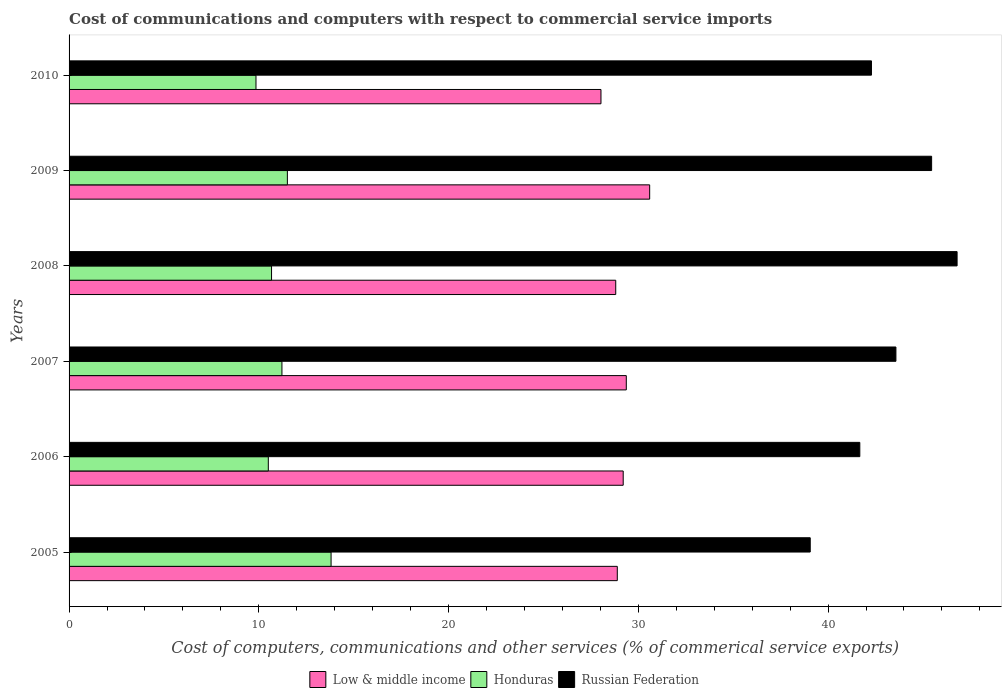How many groups of bars are there?
Your answer should be compact. 6. Are the number of bars per tick equal to the number of legend labels?
Provide a short and direct response. Yes. How many bars are there on the 6th tick from the top?
Provide a short and direct response. 3. What is the cost of communications and computers in Russian Federation in 2005?
Provide a succinct answer. 39.06. Across all years, what is the maximum cost of communications and computers in Russian Federation?
Make the answer very short. 46.8. Across all years, what is the minimum cost of communications and computers in Russian Federation?
Ensure brevity in your answer.  39.06. In which year was the cost of communications and computers in Low & middle income maximum?
Provide a succinct answer. 2009. In which year was the cost of communications and computers in Low & middle income minimum?
Provide a succinct answer. 2010. What is the total cost of communications and computers in Honduras in the graph?
Your answer should be compact. 67.55. What is the difference between the cost of communications and computers in Russian Federation in 2008 and that in 2009?
Give a very brief answer. 1.34. What is the difference between the cost of communications and computers in Low & middle income in 2005 and the cost of communications and computers in Russian Federation in 2008?
Keep it short and to the point. -17.91. What is the average cost of communications and computers in Honduras per year?
Your answer should be compact. 11.26. In the year 2010, what is the difference between the cost of communications and computers in Russian Federation and cost of communications and computers in Honduras?
Make the answer very short. 32.44. In how many years, is the cost of communications and computers in Honduras greater than 30 %?
Your response must be concise. 0. What is the ratio of the cost of communications and computers in Low & middle income in 2006 to that in 2010?
Provide a succinct answer. 1.04. Is the cost of communications and computers in Honduras in 2005 less than that in 2008?
Keep it short and to the point. No. What is the difference between the highest and the second highest cost of communications and computers in Russian Federation?
Your response must be concise. 1.34. What is the difference between the highest and the lowest cost of communications and computers in Honduras?
Make the answer very short. 3.96. In how many years, is the cost of communications and computers in Russian Federation greater than the average cost of communications and computers in Russian Federation taken over all years?
Keep it short and to the point. 3. Is the sum of the cost of communications and computers in Russian Federation in 2006 and 2007 greater than the maximum cost of communications and computers in Honduras across all years?
Make the answer very short. Yes. What does the 1st bar from the top in 2005 represents?
Make the answer very short. Russian Federation. What does the 3rd bar from the bottom in 2008 represents?
Provide a short and direct response. Russian Federation. Is it the case that in every year, the sum of the cost of communications and computers in Low & middle income and cost of communications and computers in Honduras is greater than the cost of communications and computers in Russian Federation?
Ensure brevity in your answer.  No. How many bars are there?
Provide a succinct answer. 18. Are all the bars in the graph horizontal?
Provide a succinct answer. Yes. What is the difference between two consecutive major ticks on the X-axis?
Provide a succinct answer. 10. Where does the legend appear in the graph?
Make the answer very short. Bottom center. How many legend labels are there?
Your answer should be very brief. 3. What is the title of the graph?
Your answer should be compact. Cost of communications and computers with respect to commercial service imports. Does "Heavily indebted poor countries" appear as one of the legend labels in the graph?
Provide a short and direct response. No. What is the label or title of the X-axis?
Keep it short and to the point. Cost of computers, communications and other services (% of commerical service exports). What is the Cost of computers, communications and other services (% of commerical service exports) in Low & middle income in 2005?
Your answer should be compact. 28.89. What is the Cost of computers, communications and other services (% of commerical service exports) in Honduras in 2005?
Keep it short and to the point. 13.81. What is the Cost of computers, communications and other services (% of commerical service exports) in Russian Federation in 2005?
Offer a terse response. 39.06. What is the Cost of computers, communications and other services (% of commerical service exports) of Low & middle income in 2006?
Give a very brief answer. 29.2. What is the Cost of computers, communications and other services (% of commerical service exports) in Honduras in 2006?
Make the answer very short. 10.5. What is the Cost of computers, communications and other services (% of commerical service exports) of Russian Federation in 2006?
Ensure brevity in your answer.  41.67. What is the Cost of computers, communications and other services (% of commerical service exports) of Low & middle income in 2007?
Provide a short and direct response. 29.37. What is the Cost of computers, communications and other services (% of commerical service exports) of Honduras in 2007?
Keep it short and to the point. 11.22. What is the Cost of computers, communications and other services (% of commerical service exports) of Russian Federation in 2007?
Keep it short and to the point. 43.57. What is the Cost of computers, communications and other services (% of commerical service exports) in Low & middle income in 2008?
Offer a very short reply. 28.81. What is the Cost of computers, communications and other services (% of commerical service exports) of Honduras in 2008?
Give a very brief answer. 10.67. What is the Cost of computers, communications and other services (% of commerical service exports) in Russian Federation in 2008?
Keep it short and to the point. 46.8. What is the Cost of computers, communications and other services (% of commerical service exports) of Low & middle income in 2009?
Your answer should be very brief. 30.6. What is the Cost of computers, communications and other services (% of commerical service exports) in Honduras in 2009?
Keep it short and to the point. 11.5. What is the Cost of computers, communications and other services (% of commerical service exports) of Russian Federation in 2009?
Your response must be concise. 45.46. What is the Cost of computers, communications and other services (% of commerical service exports) of Low & middle income in 2010?
Your answer should be compact. 28.03. What is the Cost of computers, communications and other services (% of commerical service exports) of Honduras in 2010?
Make the answer very short. 9.85. What is the Cost of computers, communications and other services (% of commerical service exports) of Russian Federation in 2010?
Your response must be concise. 42.29. Across all years, what is the maximum Cost of computers, communications and other services (% of commerical service exports) in Low & middle income?
Give a very brief answer. 30.6. Across all years, what is the maximum Cost of computers, communications and other services (% of commerical service exports) in Honduras?
Ensure brevity in your answer.  13.81. Across all years, what is the maximum Cost of computers, communications and other services (% of commerical service exports) of Russian Federation?
Give a very brief answer. 46.8. Across all years, what is the minimum Cost of computers, communications and other services (% of commerical service exports) in Low & middle income?
Keep it short and to the point. 28.03. Across all years, what is the minimum Cost of computers, communications and other services (% of commerical service exports) in Honduras?
Provide a short and direct response. 9.85. Across all years, what is the minimum Cost of computers, communications and other services (% of commerical service exports) of Russian Federation?
Provide a succinct answer. 39.06. What is the total Cost of computers, communications and other services (% of commerical service exports) of Low & middle income in the graph?
Provide a succinct answer. 174.9. What is the total Cost of computers, communications and other services (% of commerical service exports) in Honduras in the graph?
Keep it short and to the point. 67.55. What is the total Cost of computers, communications and other services (% of commerical service exports) in Russian Federation in the graph?
Keep it short and to the point. 258.85. What is the difference between the Cost of computers, communications and other services (% of commerical service exports) of Low & middle income in 2005 and that in 2006?
Provide a succinct answer. -0.31. What is the difference between the Cost of computers, communications and other services (% of commerical service exports) in Honduras in 2005 and that in 2006?
Your answer should be compact. 3.31. What is the difference between the Cost of computers, communications and other services (% of commerical service exports) in Russian Federation in 2005 and that in 2006?
Make the answer very short. -2.61. What is the difference between the Cost of computers, communications and other services (% of commerical service exports) of Low & middle income in 2005 and that in 2007?
Offer a terse response. -0.47. What is the difference between the Cost of computers, communications and other services (% of commerical service exports) in Honduras in 2005 and that in 2007?
Ensure brevity in your answer.  2.59. What is the difference between the Cost of computers, communications and other services (% of commerical service exports) of Russian Federation in 2005 and that in 2007?
Provide a succinct answer. -4.52. What is the difference between the Cost of computers, communications and other services (% of commerical service exports) of Low & middle income in 2005 and that in 2008?
Provide a short and direct response. 0.08. What is the difference between the Cost of computers, communications and other services (% of commerical service exports) in Honduras in 2005 and that in 2008?
Your answer should be compact. 3.14. What is the difference between the Cost of computers, communications and other services (% of commerical service exports) of Russian Federation in 2005 and that in 2008?
Provide a short and direct response. -7.74. What is the difference between the Cost of computers, communications and other services (% of commerical service exports) of Low & middle income in 2005 and that in 2009?
Provide a succinct answer. -1.71. What is the difference between the Cost of computers, communications and other services (% of commerical service exports) of Honduras in 2005 and that in 2009?
Ensure brevity in your answer.  2.3. What is the difference between the Cost of computers, communications and other services (% of commerical service exports) in Russian Federation in 2005 and that in 2009?
Offer a very short reply. -6.4. What is the difference between the Cost of computers, communications and other services (% of commerical service exports) in Low & middle income in 2005 and that in 2010?
Offer a terse response. 0.86. What is the difference between the Cost of computers, communications and other services (% of commerical service exports) in Honduras in 2005 and that in 2010?
Your answer should be very brief. 3.96. What is the difference between the Cost of computers, communications and other services (% of commerical service exports) of Russian Federation in 2005 and that in 2010?
Offer a terse response. -3.23. What is the difference between the Cost of computers, communications and other services (% of commerical service exports) in Low & middle income in 2006 and that in 2007?
Your answer should be compact. -0.16. What is the difference between the Cost of computers, communications and other services (% of commerical service exports) of Honduras in 2006 and that in 2007?
Your answer should be compact. -0.72. What is the difference between the Cost of computers, communications and other services (% of commerical service exports) of Russian Federation in 2006 and that in 2007?
Your response must be concise. -1.9. What is the difference between the Cost of computers, communications and other services (% of commerical service exports) of Low & middle income in 2006 and that in 2008?
Make the answer very short. 0.39. What is the difference between the Cost of computers, communications and other services (% of commerical service exports) in Honduras in 2006 and that in 2008?
Offer a very short reply. -0.17. What is the difference between the Cost of computers, communications and other services (% of commerical service exports) in Russian Federation in 2006 and that in 2008?
Make the answer very short. -5.13. What is the difference between the Cost of computers, communications and other services (% of commerical service exports) of Low & middle income in 2006 and that in 2009?
Provide a succinct answer. -1.4. What is the difference between the Cost of computers, communications and other services (% of commerical service exports) in Honduras in 2006 and that in 2009?
Your answer should be very brief. -1. What is the difference between the Cost of computers, communications and other services (% of commerical service exports) in Russian Federation in 2006 and that in 2009?
Keep it short and to the point. -3.78. What is the difference between the Cost of computers, communications and other services (% of commerical service exports) of Low & middle income in 2006 and that in 2010?
Keep it short and to the point. 1.17. What is the difference between the Cost of computers, communications and other services (% of commerical service exports) in Honduras in 2006 and that in 2010?
Offer a very short reply. 0.65. What is the difference between the Cost of computers, communications and other services (% of commerical service exports) of Russian Federation in 2006 and that in 2010?
Keep it short and to the point. -0.61. What is the difference between the Cost of computers, communications and other services (% of commerical service exports) in Low & middle income in 2007 and that in 2008?
Provide a succinct answer. 0.56. What is the difference between the Cost of computers, communications and other services (% of commerical service exports) of Honduras in 2007 and that in 2008?
Make the answer very short. 0.55. What is the difference between the Cost of computers, communications and other services (% of commerical service exports) in Russian Federation in 2007 and that in 2008?
Your response must be concise. -3.22. What is the difference between the Cost of computers, communications and other services (% of commerical service exports) in Low & middle income in 2007 and that in 2009?
Ensure brevity in your answer.  -1.23. What is the difference between the Cost of computers, communications and other services (% of commerical service exports) of Honduras in 2007 and that in 2009?
Ensure brevity in your answer.  -0.29. What is the difference between the Cost of computers, communications and other services (% of commerical service exports) of Russian Federation in 2007 and that in 2009?
Provide a succinct answer. -1.88. What is the difference between the Cost of computers, communications and other services (% of commerical service exports) in Low & middle income in 2007 and that in 2010?
Give a very brief answer. 1.33. What is the difference between the Cost of computers, communications and other services (% of commerical service exports) in Honduras in 2007 and that in 2010?
Provide a succinct answer. 1.37. What is the difference between the Cost of computers, communications and other services (% of commerical service exports) in Russian Federation in 2007 and that in 2010?
Offer a very short reply. 1.29. What is the difference between the Cost of computers, communications and other services (% of commerical service exports) in Low & middle income in 2008 and that in 2009?
Your answer should be compact. -1.79. What is the difference between the Cost of computers, communications and other services (% of commerical service exports) of Honduras in 2008 and that in 2009?
Offer a terse response. -0.83. What is the difference between the Cost of computers, communications and other services (% of commerical service exports) of Russian Federation in 2008 and that in 2009?
Offer a very short reply. 1.34. What is the difference between the Cost of computers, communications and other services (% of commerical service exports) in Low & middle income in 2008 and that in 2010?
Give a very brief answer. 0.78. What is the difference between the Cost of computers, communications and other services (% of commerical service exports) of Honduras in 2008 and that in 2010?
Keep it short and to the point. 0.82. What is the difference between the Cost of computers, communications and other services (% of commerical service exports) in Russian Federation in 2008 and that in 2010?
Make the answer very short. 4.51. What is the difference between the Cost of computers, communications and other services (% of commerical service exports) in Low & middle income in 2009 and that in 2010?
Offer a terse response. 2.57. What is the difference between the Cost of computers, communications and other services (% of commerical service exports) of Honduras in 2009 and that in 2010?
Your answer should be compact. 1.65. What is the difference between the Cost of computers, communications and other services (% of commerical service exports) in Russian Federation in 2009 and that in 2010?
Offer a terse response. 3.17. What is the difference between the Cost of computers, communications and other services (% of commerical service exports) of Low & middle income in 2005 and the Cost of computers, communications and other services (% of commerical service exports) of Honduras in 2006?
Your response must be concise. 18.39. What is the difference between the Cost of computers, communications and other services (% of commerical service exports) of Low & middle income in 2005 and the Cost of computers, communications and other services (% of commerical service exports) of Russian Federation in 2006?
Ensure brevity in your answer.  -12.78. What is the difference between the Cost of computers, communications and other services (% of commerical service exports) in Honduras in 2005 and the Cost of computers, communications and other services (% of commerical service exports) in Russian Federation in 2006?
Offer a terse response. -27.86. What is the difference between the Cost of computers, communications and other services (% of commerical service exports) of Low & middle income in 2005 and the Cost of computers, communications and other services (% of commerical service exports) of Honduras in 2007?
Provide a succinct answer. 17.67. What is the difference between the Cost of computers, communications and other services (% of commerical service exports) of Low & middle income in 2005 and the Cost of computers, communications and other services (% of commerical service exports) of Russian Federation in 2007?
Offer a terse response. -14.68. What is the difference between the Cost of computers, communications and other services (% of commerical service exports) of Honduras in 2005 and the Cost of computers, communications and other services (% of commerical service exports) of Russian Federation in 2007?
Your answer should be compact. -29.77. What is the difference between the Cost of computers, communications and other services (% of commerical service exports) of Low & middle income in 2005 and the Cost of computers, communications and other services (% of commerical service exports) of Honduras in 2008?
Keep it short and to the point. 18.22. What is the difference between the Cost of computers, communications and other services (% of commerical service exports) of Low & middle income in 2005 and the Cost of computers, communications and other services (% of commerical service exports) of Russian Federation in 2008?
Offer a very short reply. -17.91. What is the difference between the Cost of computers, communications and other services (% of commerical service exports) of Honduras in 2005 and the Cost of computers, communications and other services (% of commerical service exports) of Russian Federation in 2008?
Ensure brevity in your answer.  -32.99. What is the difference between the Cost of computers, communications and other services (% of commerical service exports) in Low & middle income in 2005 and the Cost of computers, communications and other services (% of commerical service exports) in Honduras in 2009?
Keep it short and to the point. 17.39. What is the difference between the Cost of computers, communications and other services (% of commerical service exports) in Low & middle income in 2005 and the Cost of computers, communications and other services (% of commerical service exports) in Russian Federation in 2009?
Your answer should be very brief. -16.57. What is the difference between the Cost of computers, communications and other services (% of commerical service exports) of Honduras in 2005 and the Cost of computers, communications and other services (% of commerical service exports) of Russian Federation in 2009?
Your answer should be very brief. -31.65. What is the difference between the Cost of computers, communications and other services (% of commerical service exports) of Low & middle income in 2005 and the Cost of computers, communications and other services (% of commerical service exports) of Honduras in 2010?
Give a very brief answer. 19.04. What is the difference between the Cost of computers, communications and other services (% of commerical service exports) of Low & middle income in 2005 and the Cost of computers, communications and other services (% of commerical service exports) of Russian Federation in 2010?
Your answer should be compact. -13.4. What is the difference between the Cost of computers, communications and other services (% of commerical service exports) of Honduras in 2005 and the Cost of computers, communications and other services (% of commerical service exports) of Russian Federation in 2010?
Offer a very short reply. -28.48. What is the difference between the Cost of computers, communications and other services (% of commerical service exports) of Low & middle income in 2006 and the Cost of computers, communications and other services (% of commerical service exports) of Honduras in 2007?
Ensure brevity in your answer.  17.98. What is the difference between the Cost of computers, communications and other services (% of commerical service exports) in Low & middle income in 2006 and the Cost of computers, communications and other services (% of commerical service exports) in Russian Federation in 2007?
Provide a succinct answer. -14.37. What is the difference between the Cost of computers, communications and other services (% of commerical service exports) in Honduras in 2006 and the Cost of computers, communications and other services (% of commerical service exports) in Russian Federation in 2007?
Ensure brevity in your answer.  -33.07. What is the difference between the Cost of computers, communications and other services (% of commerical service exports) of Low & middle income in 2006 and the Cost of computers, communications and other services (% of commerical service exports) of Honduras in 2008?
Provide a short and direct response. 18.53. What is the difference between the Cost of computers, communications and other services (% of commerical service exports) of Low & middle income in 2006 and the Cost of computers, communications and other services (% of commerical service exports) of Russian Federation in 2008?
Your answer should be compact. -17.6. What is the difference between the Cost of computers, communications and other services (% of commerical service exports) in Honduras in 2006 and the Cost of computers, communications and other services (% of commerical service exports) in Russian Federation in 2008?
Provide a succinct answer. -36.3. What is the difference between the Cost of computers, communications and other services (% of commerical service exports) of Low & middle income in 2006 and the Cost of computers, communications and other services (% of commerical service exports) of Honduras in 2009?
Your answer should be very brief. 17.7. What is the difference between the Cost of computers, communications and other services (% of commerical service exports) in Low & middle income in 2006 and the Cost of computers, communications and other services (% of commerical service exports) in Russian Federation in 2009?
Keep it short and to the point. -16.25. What is the difference between the Cost of computers, communications and other services (% of commerical service exports) in Honduras in 2006 and the Cost of computers, communications and other services (% of commerical service exports) in Russian Federation in 2009?
Give a very brief answer. -34.96. What is the difference between the Cost of computers, communications and other services (% of commerical service exports) of Low & middle income in 2006 and the Cost of computers, communications and other services (% of commerical service exports) of Honduras in 2010?
Give a very brief answer. 19.35. What is the difference between the Cost of computers, communications and other services (% of commerical service exports) in Low & middle income in 2006 and the Cost of computers, communications and other services (% of commerical service exports) in Russian Federation in 2010?
Offer a terse response. -13.08. What is the difference between the Cost of computers, communications and other services (% of commerical service exports) in Honduras in 2006 and the Cost of computers, communications and other services (% of commerical service exports) in Russian Federation in 2010?
Offer a very short reply. -31.79. What is the difference between the Cost of computers, communications and other services (% of commerical service exports) in Low & middle income in 2007 and the Cost of computers, communications and other services (% of commerical service exports) in Honduras in 2008?
Your answer should be very brief. 18.7. What is the difference between the Cost of computers, communications and other services (% of commerical service exports) of Low & middle income in 2007 and the Cost of computers, communications and other services (% of commerical service exports) of Russian Federation in 2008?
Provide a short and direct response. -17.43. What is the difference between the Cost of computers, communications and other services (% of commerical service exports) in Honduras in 2007 and the Cost of computers, communications and other services (% of commerical service exports) in Russian Federation in 2008?
Your response must be concise. -35.58. What is the difference between the Cost of computers, communications and other services (% of commerical service exports) in Low & middle income in 2007 and the Cost of computers, communications and other services (% of commerical service exports) in Honduras in 2009?
Provide a short and direct response. 17.86. What is the difference between the Cost of computers, communications and other services (% of commerical service exports) in Low & middle income in 2007 and the Cost of computers, communications and other services (% of commerical service exports) in Russian Federation in 2009?
Give a very brief answer. -16.09. What is the difference between the Cost of computers, communications and other services (% of commerical service exports) in Honduras in 2007 and the Cost of computers, communications and other services (% of commerical service exports) in Russian Federation in 2009?
Your response must be concise. -34.24. What is the difference between the Cost of computers, communications and other services (% of commerical service exports) of Low & middle income in 2007 and the Cost of computers, communications and other services (% of commerical service exports) of Honduras in 2010?
Offer a terse response. 19.52. What is the difference between the Cost of computers, communications and other services (% of commerical service exports) of Low & middle income in 2007 and the Cost of computers, communications and other services (% of commerical service exports) of Russian Federation in 2010?
Keep it short and to the point. -12.92. What is the difference between the Cost of computers, communications and other services (% of commerical service exports) in Honduras in 2007 and the Cost of computers, communications and other services (% of commerical service exports) in Russian Federation in 2010?
Make the answer very short. -31.07. What is the difference between the Cost of computers, communications and other services (% of commerical service exports) of Low & middle income in 2008 and the Cost of computers, communications and other services (% of commerical service exports) of Honduras in 2009?
Your answer should be very brief. 17.3. What is the difference between the Cost of computers, communications and other services (% of commerical service exports) of Low & middle income in 2008 and the Cost of computers, communications and other services (% of commerical service exports) of Russian Federation in 2009?
Offer a very short reply. -16.65. What is the difference between the Cost of computers, communications and other services (% of commerical service exports) of Honduras in 2008 and the Cost of computers, communications and other services (% of commerical service exports) of Russian Federation in 2009?
Offer a terse response. -34.79. What is the difference between the Cost of computers, communications and other services (% of commerical service exports) of Low & middle income in 2008 and the Cost of computers, communications and other services (% of commerical service exports) of Honduras in 2010?
Offer a very short reply. 18.96. What is the difference between the Cost of computers, communications and other services (% of commerical service exports) in Low & middle income in 2008 and the Cost of computers, communications and other services (% of commerical service exports) in Russian Federation in 2010?
Ensure brevity in your answer.  -13.48. What is the difference between the Cost of computers, communications and other services (% of commerical service exports) in Honduras in 2008 and the Cost of computers, communications and other services (% of commerical service exports) in Russian Federation in 2010?
Your answer should be very brief. -31.62. What is the difference between the Cost of computers, communications and other services (% of commerical service exports) of Low & middle income in 2009 and the Cost of computers, communications and other services (% of commerical service exports) of Honduras in 2010?
Your answer should be very brief. 20.75. What is the difference between the Cost of computers, communications and other services (% of commerical service exports) in Low & middle income in 2009 and the Cost of computers, communications and other services (% of commerical service exports) in Russian Federation in 2010?
Provide a short and direct response. -11.69. What is the difference between the Cost of computers, communications and other services (% of commerical service exports) in Honduras in 2009 and the Cost of computers, communications and other services (% of commerical service exports) in Russian Federation in 2010?
Your response must be concise. -30.78. What is the average Cost of computers, communications and other services (% of commerical service exports) of Low & middle income per year?
Keep it short and to the point. 29.15. What is the average Cost of computers, communications and other services (% of commerical service exports) in Honduras per year?
Offer a terse response. 11.26. What is the average Cost of computers, communications and other services (% of commerical service exports) of Russian Federation per year?
Make the answer very short. 43.14. In the year 2005, what is the difference between the Cost of computers, communications and other services (% of commerical service exports) in Low & middle income and Cost of computers, communications and other services (% of commerical service exports) in Honduras?
Your answer should be very brief. 15.08. In the year 2005, what is the difference between the Cost of computers, communications and other services (% of commerical service exports) of Low & middle income and Cost of computers, communications and other services (% of commerical service exports) of Russian Federation?
Your answer should be compact. -10.17. In the year 2005, what is the difference between the Cost of computers, communications and other services (% of commerical service exports) in Honduras and Cost of computers, communications and other services (% of commerical service exports) in Russian Federation?
Provide a short and direct response. -25.25. In the year 2006, what is the difference between the Cost of computers, communications and other services (% of commerical service exports) in Low & middle income and Cost of computers, communications and other services (% of commerical service exports) in Honduras?
Give a very brief answer. 18.7. In the year 2006, what is the difference between the Cost of computers, communications and other services (% of commerical service exports) of Low & middle income and Cost of computers, communications and other services (% of commerical service exports) of Russian Federation?
Your response must be concise. -12.47. In the year 2006, what is the difference between the Cost of computers, communications and other services (% of commerical service exports) in Honduras and Cost of computers, communications and other services (% of commerical service exports) in Russian Federation?
Provide a succinct answer. -31.17. In the year 2007, what is the difference between the Cost of computers, communications and other services (% of commerical service exports) of Low & middle income and Cost of computers, communications and other services (% of commerical service exports) of Honduras?
Give a very brief answer. 18.15. In the year 2007, what is the difference between the Cost of computers, communications and other services (% of commerical service exports) in Low & middle income and Cost of computers, communications and other services (% of commerical service exports) in Russian Federation?
Make the answer very short. -14.21. In the year 2007, what is the difference between the Cost of computers, communications and other services (% of commerical service exports) in Honduras and Cost of computers, communications and other services (% of commerical service exports) in Russian Federation?
Provide a succinct answer. -32.36. In the year 2008, what is the difference between the Cost of computers, communications and other services (% of commerical service exports) of Low & middle income and Cost of computers, communications and other services (% of commerical service exports) of Honduras?
Offer a very short reply. 18.14. In the year 2008, what is the difference between the Cost of computers, communications and other services (% of commerical service exports) in Low & middle income and Cost of computers, communications and other services (% of commerical service exports) in Russian Federation?
Your response must be concise. -17.99. In the year 2008, what is the difference between the Cost of computers, communications and other services (% of commerical service exports) in Honduras and Cost of computers, communications and other services (% of commerical service exports) in Russian Federation?
Offer a terse response. -36.13. In the year 2009, what is the difference between the Cost of computers, communications and other services (% of commerical service exports) of Low & middle income and Cost of computers, communications and other services (% of commerical service exports) of Honduras?
Your response must be concise. 19.09. In the year 2009, what is the difference between the Cost of computers, communications and other services (% of commerical service exports) of Low & middle income and Cost of computers, communications and other services (% of commerical service exports) of Russian Federation?
Make the answer very short. -14.86. In the year 2009, what is the difference between the Cost of computers, communications and other services (% of commerical service exports) of Honduras and Cost of computers, communications and other services (% of commerical service exports) of Russian Federation?
Your answer should be compact. -33.95. In the year 2010, what is the difference between the Cost of computers, communications and other services (% of commerical service exports) of Low & middle income and Cost of computers, communications and other services (% of commerical service exports) of Honduras?
Your answer should be very brief. 18.18. In the year 2010, what is the difference between the Cost of computers, communications and other services (% of commerical service exports) in Low & middle income and Cost of computers, communications and other services (% of commerical service exports) in Russian Federation?
Offer a terse response. -14.26. In the year 2010, what is the difference between the Cost of computers, communications and other services (% of commerical service exports) in Honduras and Cost of computers, communications and other services (% of commerical service exports) in Russian Federation?
Offer a terse response. -32.44. What is the ratio of the Cost of computers, communications and other services (% of commerical service exports) of Low & middle income in 2005 to that in 2006?
Keep it short and to the point. 0.99. What is the ratio of the Cost of computers, communications and other services (% of commerical service exports) in Honduras in 2005 to that in 2006?
Give a very brief answer. 1.31. What is the ratio of the Cost of computers, communications and other services (% of commerical service exports) in Russian Federation in 2005 to that in 2006?
Make the answer very short. 0.94. What is the ratio of the Cost of computers, communications and other services (% of commerical service exports) of Low & middle income in 2005 to that in 2007?
Ensure brevity in your answer.  0.98. What is the ratio of the Cost of computers, communications and other services (% of commerical service exports) of Honduras in 2005 to that in 2007?
Make the answer very short. 1.23. What is the ratio of the Cost of computers, communications and other services (% of commerical service exports) in Russian Federation in 2005 to that in 2007?
Give a very brief answer. 0.9. What is the ratio of the Cost of computers, communications and other services (% of commerical service exports) of Honduras in 2005 to that in 2008?
Offer a very short reply. 1.29. What is the ratio of the Cost of computers, communications and other services (% of commerical service exports) in Russian Federation in 2005 to that in 2008?
Keep it short and to the point. 0.83. What is the ratio of the Cost of computers, communications and other services (% of commerical service exports) of Low & middle income in 2005 to that in 2009?
Offer a very short reply. 0.94. What is the ratio of the Cost of computers, communications and other services (% of commerical service exports) in Honduras in 2005 to that in 2009?
Your answer should be very brief. 1.2. What is the ratio of the Cost of computers, communications and other services (% of commerical service exports) in Russian Federation in 2005 to that in 2009?
Offer a very short reply. 0.86. What is the ratio of the Cost of computers, communications and other services (% of commerical service exports) in Low & middle income in 2005 to that in 2010?
Provide a succinct answer. 1.03. What is the ratio of the Cost of computers, communications and other services (% of commerical service exports) of Honduras in 2005 to that in 2010?
Ensure brevity in your answer.  1.4. What is the ratio of the Cost of computers, communications and other services (% of commerical service exports) in Russian Federation in 2005 to that in 2010?
Make the answer very short. 0.92. What is the ratio of the Cost of computers, communications and other services (% of commerical service exports) of Honduras in 2006 to that in 2007?
Provide a succinct answer. 0.94. What is the ratio of the Cost of computers, communications and other services (% of commerical service exports) of Russian Federation in 2006 to that in 2007?
Provide a short and direct response. 0.96. What is the ratio of the Cost of computers, communications and other services (% of commerical service exports) of Low & middle income in 2006 to that in 2008?
Make the answer very short. 1.01. What is the ratio of the Cost of computers, communications and other services (% of commerical service exports) of Russian Federation in 2006 to that in 2008?
Give a very brief answer. 0.89. What is the ratio of the Cost of computers, communications and other services (% of commerical service exports) in Low & middle income in 2006 to that in 2009?
Offer a terse response. 0.95. What is the ratio of the Cost of computers, communications and other services (% of commerical service exports) in Honduras in 2006 to that in 2009?
Your response must be concise. 0.91. What is the ratio of the Cost of computers, communications and other services (% of commerical service exports) of Russian Federation in 2006 to that in 2009?
Your response must be concise. 0.92. What is the ratio of the Cost of computers, communications and other services (% of commerical service exports) in Low & middle income in 2006 to that in 2010?
Make the answer very short. 1.04. What is the ratio of the Cost of computers, communications and other services (% of commerical service exports) of Honduras in 2006 to that in 2010?
Your answer should be compact. 1.07. What is the ratio of the Cost of computers, communications and other services (% of commerical service exports) of Russian Federation in 2006 to that in 2010?
Give a very brief answer. 0.99. What is the ratio of the Cost of computers, communications and other services (% of commerical service exports) in Low & middle income in 2007 to that in 2008?
Your answer should be compact. 1.02. What is the ratio of the Cost of computers, communications and other services (% of commerical service exports) in Honduras in 2007 to that in 2008?
Make the answer very short. 1.05. What is the ratio of the Cost of computers, communications and other services (% of commerical service exports) of Russian Federation in 2007 to that in 2008?
Ensure brevity in your answer.  0.93. What is the ratio of the Cost of computers, communications and other services (% of commerical service exports) in Low & middle income in 2007 to that in 2009?
Your answer should be compact. 0.96. What is the ratio of the Cost of computers, communications and other services (% of commerical service exports) in Honduras in 2007 to that in 2009?
Provide a short and direct response. 0.98. What is the ratio of the Cost of computers, communications and other services (% of commerical service exports) in Russian Federation in 2007 to that in 2009?
Offer a terse response. 0.96. What is the ratio of the Cost of computers, communications and other services (% of commerical service exports) in Low & middle income in 2007 to that in 2010?
Give a very brief answer. 1.05. What is the ratio of the Cost of computers, communications and other services (% of commerical service exports) in Honduras in 2007 to that in 2010?
Provide a succinct answer. 1.14. What is the ratio of the Cost of computers, communications and other services (% of commerical service exports) of Russian Federation in 2007 to that in 2010?
Provide a succinct answer. 1.03. What is the ratio of the Cost of computers, communications and other services (% of commerical service exports) of Low & middle income in 2008 to that in 2009?
Offer a very short reply. 0.94. What is the ratio of the Cost of computers, communications and other services (% of commerical service exports) of Honduras in 2008 to that in 2009?
Provide a succinct answer. 0.93. What is the ratio of the Cost of computers, communications and other services (% of commerical service exports) in Russian Federation in 2008 to that in 2009?
Give a very brief answer. 1.03. What is the ratio of the Cost of computers, communications and other services (% of commerical service exports) of Low & middle income in 2008 to that in 2010?
Your response must be concise. 1.03. What is the ratio of the Cost of computers, communications and other services (% of commerical service exports) in Honduras in 2008 to that in 2010?
Make the answer very short. 1.08. What is the ratio of the Cost of computers, communications and other services (% of commerical service exports) in Russian Federation in 2008 to that in 2010?
Offer a very short reply. 1.11. What is the ratio of the Cost of computers, communications and other services (% of commerical service exports) of Low & middle income in 2009 to that in 2010?
Ensure brevity in your answer.  1.09. What is the ratio of the Cost of computers, communications and other services (% of commerical service exports) of Honduras in 2009 to that in 2010?
Your answer should be very brief. 1.17. What is the ratio of the Cost of computers, communications and other services (% of commerical service exports) of Russian Federation in 2009 to that in 2010?
Your answer should be compact. 1.07. What is the difference between the highest and the second highest Cost of computers, communications and other services (% of commerical service exports) in Low & middle income?
Your answer should be compact. 1.23. What is the difference between the highest and the second highest Cost of computers, communications and other services (% of commerical service exports) in Honduras?
Keep it short and to the point. 2.3. What is the difference between the highest and the second highest Cost of computers, communications and other services (% of commerical service exports) of Russian Federation?
Your answer should be compact. 1.34. What is the difference between the highest and the lowest Cost of computers, communications and other services (% of commerical service exports) of Low & middle income?
Provide a short and direct response. 2.57. What is the difference between the highest and the lowest Cost of computers, communications and other services (% of commerical service exports) in Honduras?
Offer a terse response. 3.96. What is the difference between the highest and the lowest Cost of computers, communications and other services (% of commerical service exports) of Russian Federation?
Make the answer very short. 7.74. 